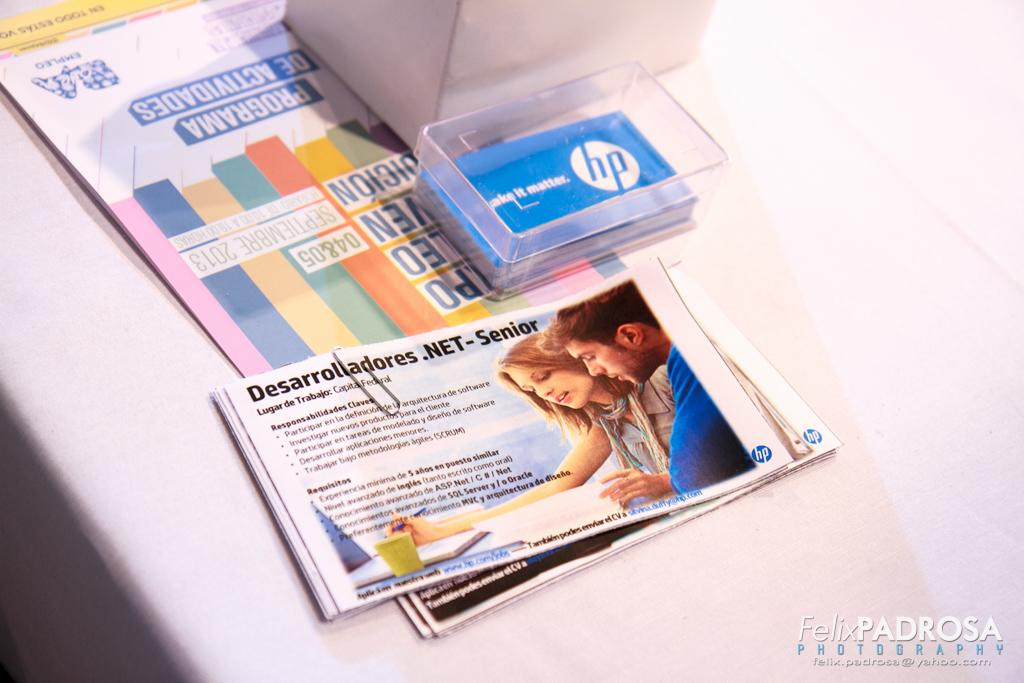What type of items are stored in the box in the image? There are cards in a box in the image. What other paper-based items can be seen in the image? There are papers and pamphlets with a paper clip in the image. Where is the box located in the image? The box is on the table in the image. What might be used to hold multiple sheets of paper together in the image? A paper clip is used to hold multiple sheets of paper together in the image. What type of tax is being discussed on the pamphlets in the image? There is no mention of tax on the pamphlets in the image. Can you describe the house that is visible in the image? There is no house visible in the image. 